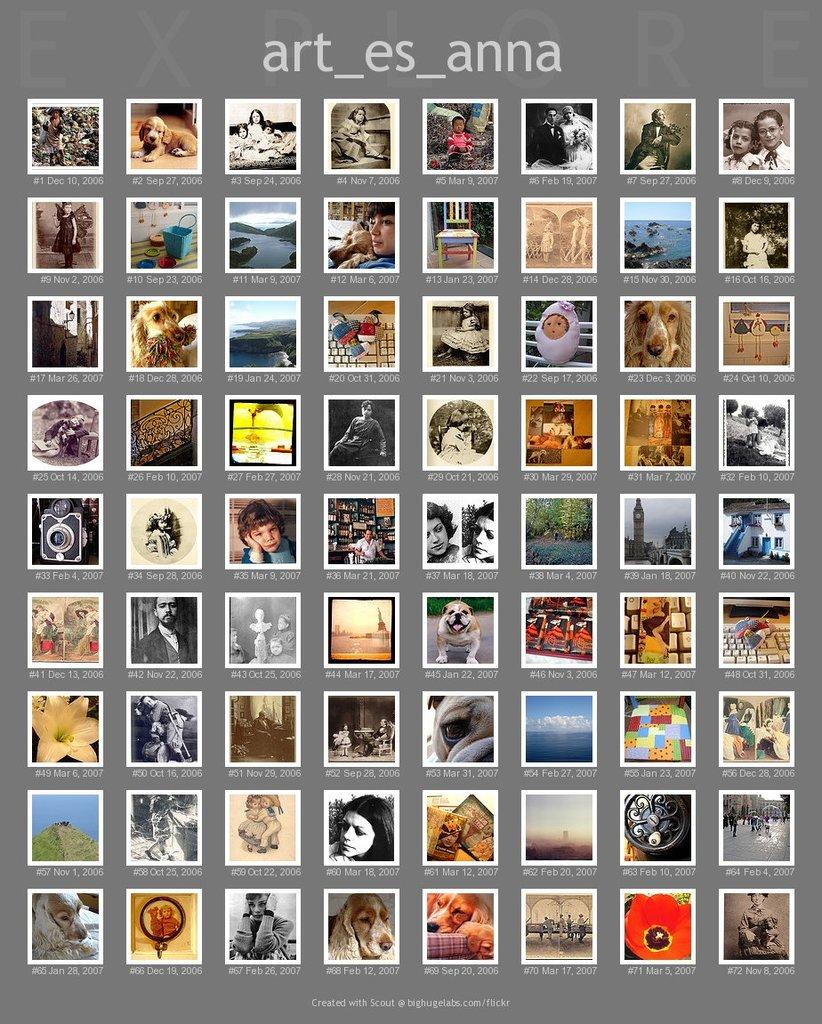What type of photo is shown in the image? The image is a collage photo. Who or what can be seen in the collage photo? There are a group of people and animals in the collage photo. What natural elements are present in the collage photo? There are trees, water, and the sky in the collage photo. Can you see a footprint in the water in the image? There is no footprint visible in the water in the image. What type of cup is being used by the animals in the image? There are no cups present in the image, as it features a collage of people, animals, trees, water, and the sky. 